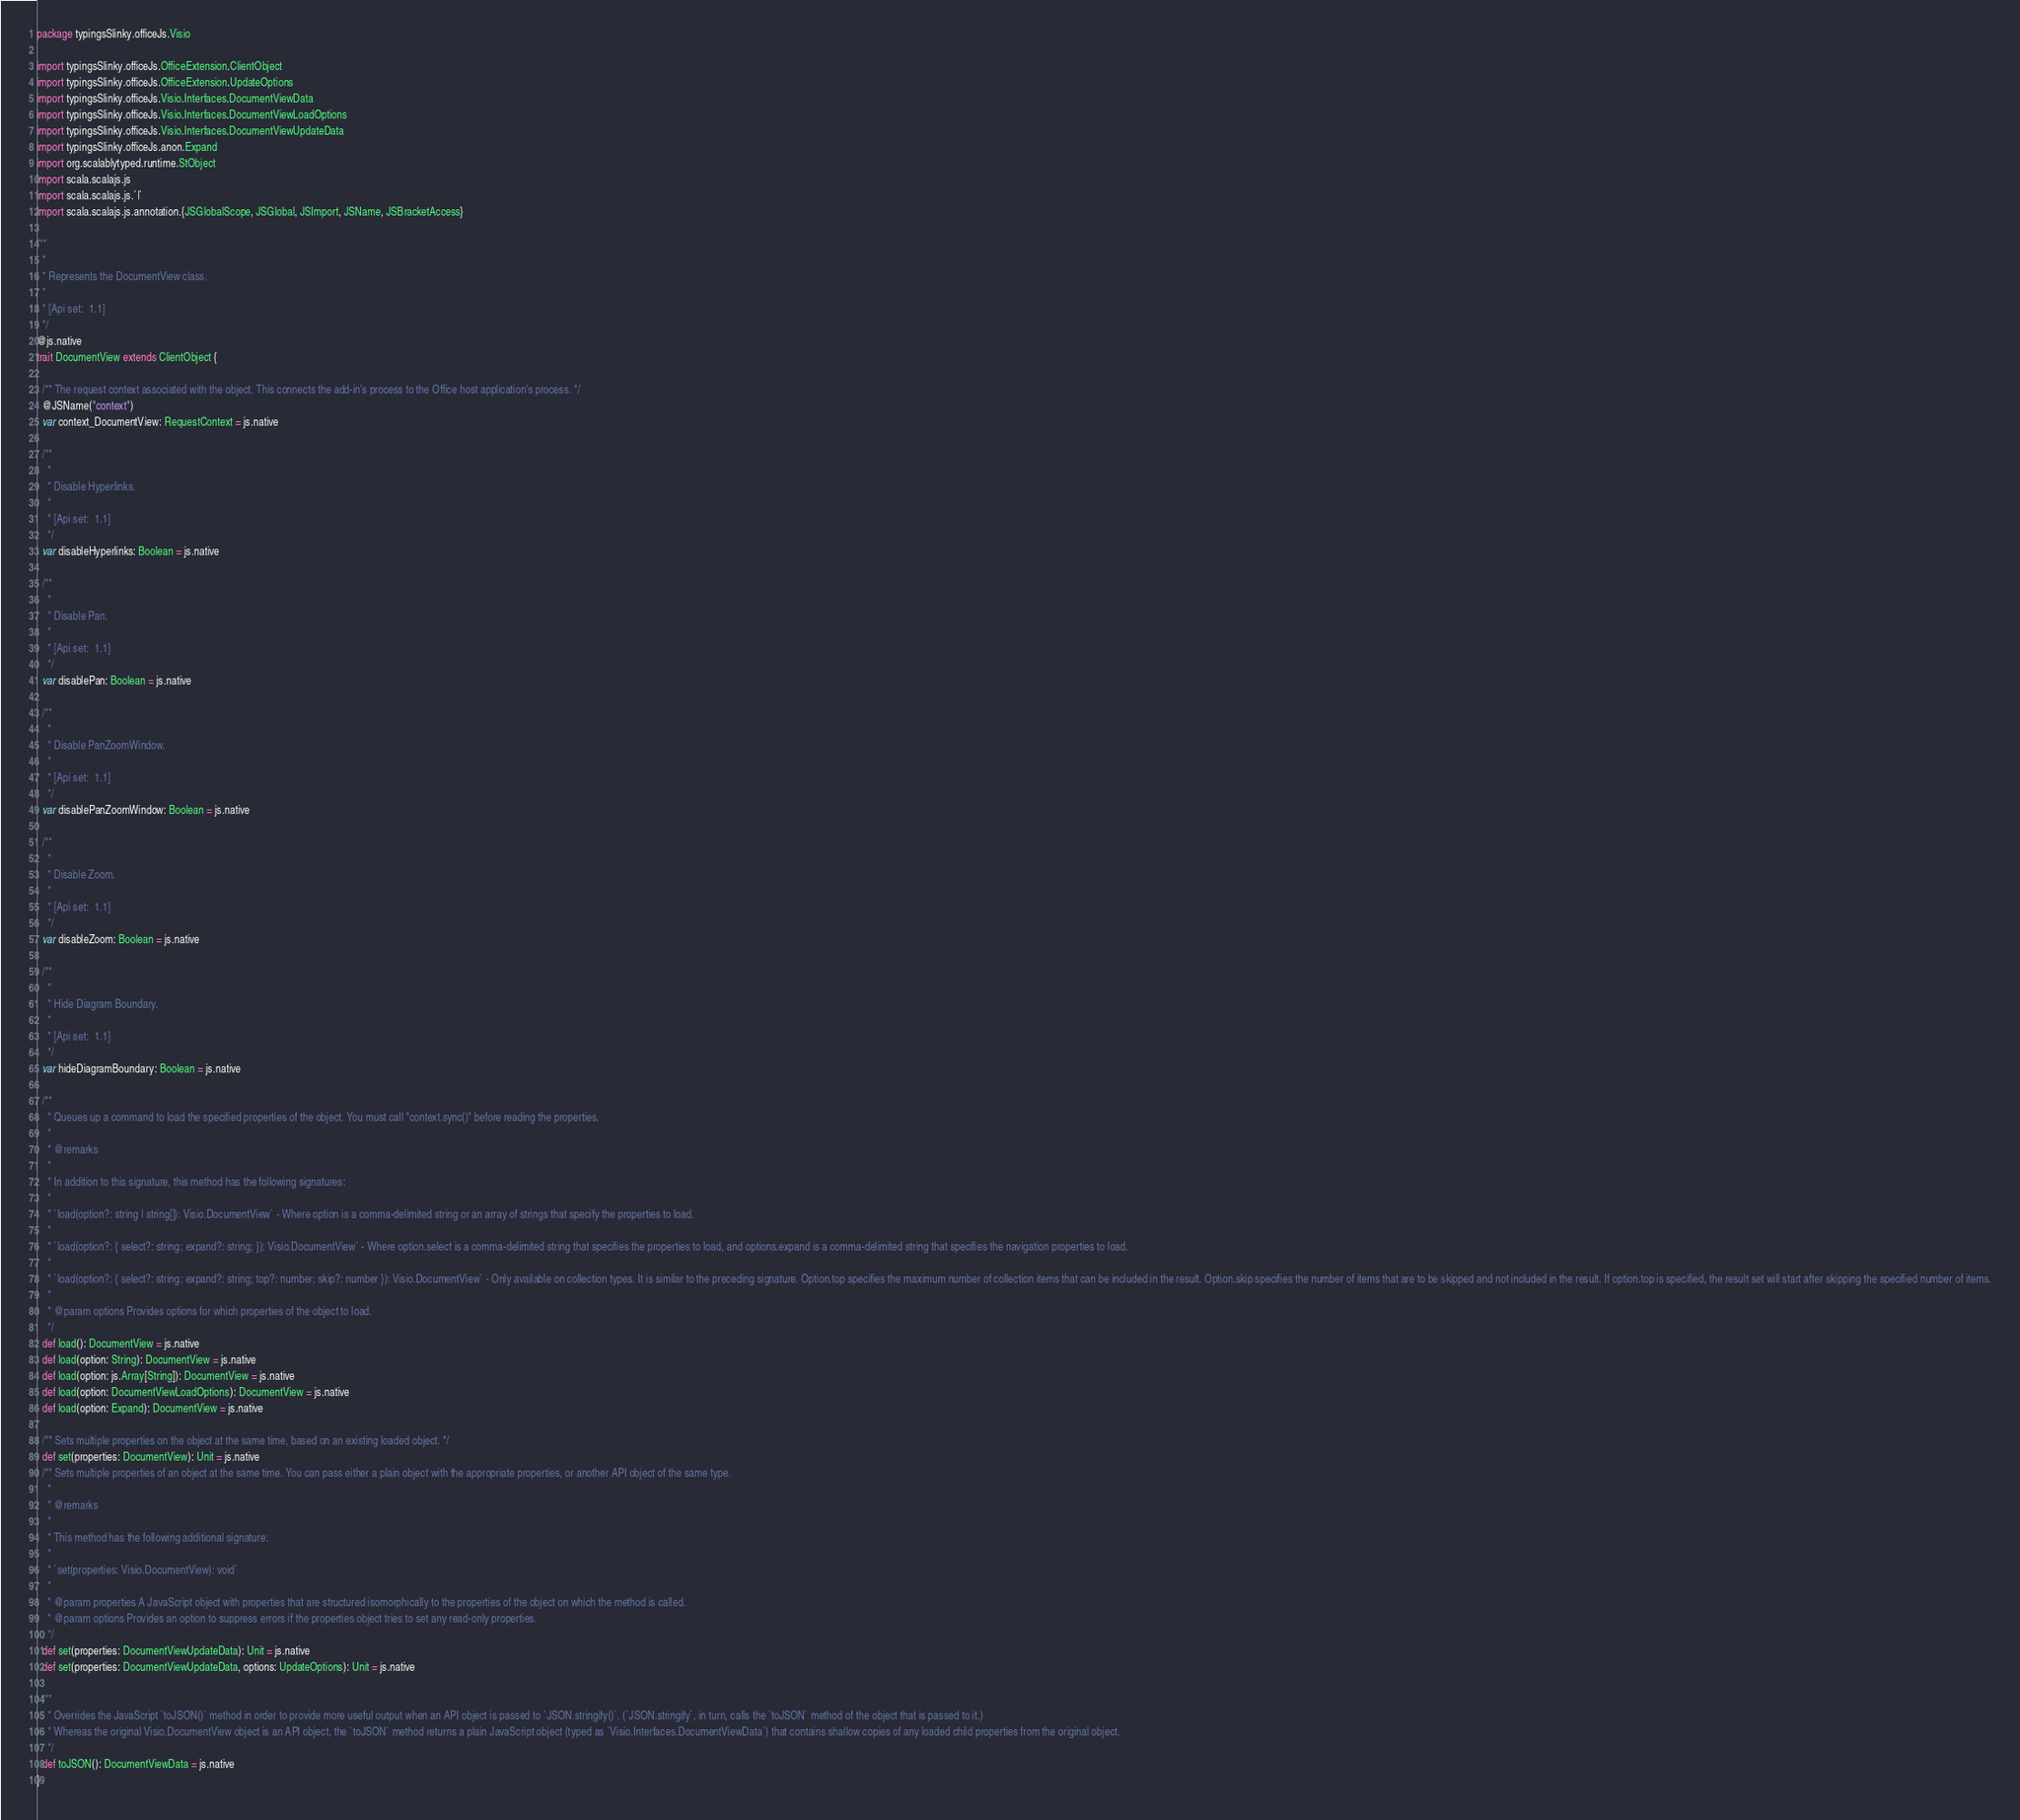<code> <loc_0><loc_0><loc_500><loc_500><_Scala_>package typingsSlinky.officeJs.Visio

import typingsSlinky.officeJs.OfficeExtension.ClientObject
import typingsSlinky.officeJs.OfficeExtension.UpdateOptions
import typingsSlinky.officeJs.Visio.Interfaces.DocumentViewData
import typingsSlinky.officeJs.Visio.Interfaces.DocumentViewLoadOptions
import typingsSlinky.officeJs.Visio.Interfaces.DocumentViewUpdateData
import typingsSlinky.officeJs.anon.Expand
import org.scalablytyped.runtime.StObject
import scala.scalajs.js
import scala.scalajs.js.`|`
import scala.scalajs.js.annotation.{JSGlobalScope, JSGlobal, JSImport, JSName, JSBracketAccess}

/**
  *
  * Represents the DocumentView class.
  *
  * [Api set:  1.1]
  */
@js.native
trait DocumentView extends ClientObject {
  
  /** The request context associated with the object. This connects the add-in's process to the Office host application's process. */
  @JSName("context")
  var context_DocumentView: RequestContext = js.native
  
  /**
    *
    * Disable Hyperlinks.
    *
    * [Api set:  1.1]
    */
  var disableHyperlinks: Boolean = js.native
  
  /**
    *
    * Disable Pan.
    *
    * [Api set:  1.1]
    */
  var disablePan: Boolean = js.native
  
  /**
    *
    * Disable PanZoomWindow.
    *
    * [Api set:  1.1]
    */
  var disablePanZoomWindow: Boolean = js.native
  
  /**
    *
    * Disable Zoom.
    *
    * [Api set:  1.1]
    */
  var disableZoom: Boolean = js.native
  
  /**
    *
    * Hide Diagram Boundary.
    *
    * [Api set:  1.1]
    */
  var hideDiagramBoundary: Boolean = js.native
  
  /**
    * Queues up a command to load the specified properties of the object. You must call "context.sync()" before reading the properties.
    *
    * @remarks
    *
    * In addition to this signature, this method has the following signatures:
    *
    * `load(option?: string | string[]): Visio.DocumentView` - Where option is a comma-delimited string or an array of strings that specify the properties to load.
    *
    * `load(option?: { select?: string; expand?: string; }): Visio.DocumentView` - Where option.select is a comma-delimited string that specifies the properties to load, and options.expand is a comma-delimited string that specifies the navigation properties to load.
    *
    * `load(option?: { select?: string; expand?: string; top?: number; skip?: number }): Visio.DocumentView` - Only available on collection types. It is similar to the preceding signature. Option.top specifies the maximum number of collection items that can be included in the result. Option.skip specifies the number of items that are to be skipped and not included in the result. If option.top is specified, the result set will start after skipping the specified number of items.
    *
    * @param options Provides options for which properties of the object to load.
    */
  def load(): DocumentView = js.native
  def load(option: String): DocumentView = js.native
  def load(option: js.Array[String]): DocumentView = js.native
  def load(option: DocumentViewLoadOptions): DocumentView = js.native
  def load(option: Expand): DocumentView = js.native
  
  /** Sets multiple properties on the object at the same time, based on an existing loaded object. */
  def set(properties: DocumentView): Unit = js.native
  /** Sets multiple properties of an object at the same time. You can pass either a plain object with the appropriate properties, or another API object of the same type.
    *
    * @remarks
    *
    * This method has the following additional signature:
    *
    * `set(properties: Visio.DocumentView): void`
    *
    * @param properties A JavaScript object with properties that are structured isomorphically to the properties of the object on which the method is called.
    * @param options Provides an option to suppress errors if the properties object tries to set any read-only properties.
    */
  def set(properties: DocumentViewUpdateData): Unit = js.native
  def set(properties: DocumentViewUpdateData, options: UpdateOptions): Unit = js.native
  
  /**
    * Overrides the JavaScript `toJSON()` method in order to provide more useful output when an API object is passed to `JSON.stringify()`. (`JSON.stringify`, in turn, calls the `toJSON` method of the object that is passed to it.)
    * Whereas the original Visio.DocumentView object is an API object, the `toJSON` method returns a plain JavaScript object (typed as `Visio.Interfaces.DocumentViewData`) that contains shallow copies of any loaded child properties from the original object.
    */
  def toJSON(): DocumentViewData = js.native
}
</code> 